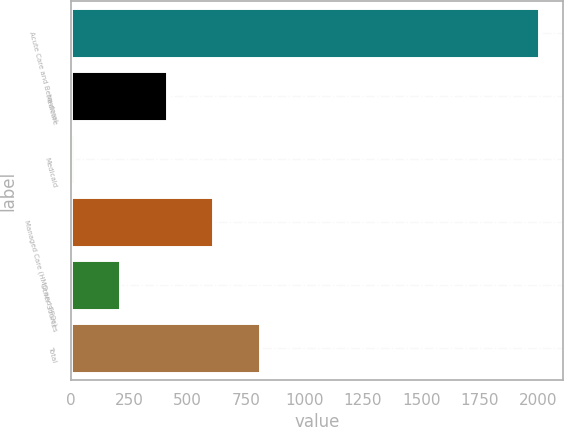<chart> <loc_0><loc_0><loc_500><loc_500><bar_chart><fcel>Acute Care and Behavioral<fcel>Medicare<fcel>Medicaid<fcel>Managed Care (HMO and PPOs)<fcel>Other Sources<fcel>Total<nl><fcel>2006<fcel>411.6<fcel>13<fcel>610.9<fcel>212.3<fcel>810.2<nl></chart> 